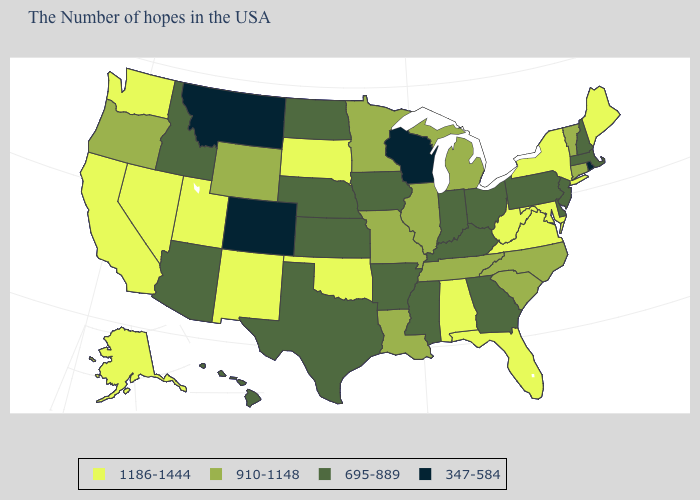What is the highest value in the USA?
Write a very short answer. 1186-1444. How many symbols are there in the legend?
Write a very short answer. 4. What is the value of Connecticut?
Answer briefly. 910-1148. Is the legend a continuous bar?
Quick response, please. No. Which states have the highest value in the USA?
Be succinct. Maine, New York, Maryland, Virginia, West Virginia, Florida, Alabama, Oklahoma, South Dakota, New Mexico, Utah, Nevada, California, Washington, Alaska. Does Iowa have the highest value in the USA?
Answer briefly. No. Is the legend a continuous bar?
Quick response, please. No. Does New Hampshire have the lowest value in the Northeast?
Write a very short answer. No. Among the states that border Arkansas , does Oklahoma have the highest value?
Short answer required. Yes. What is the value of Idaho?
Quick response, please. 695-889. What is the lowest value in states that border Maryland?
Give a very brief answer. 695-889. Does Missouri have the same value as Minnesota?
Concise answer only. Yes. Among the states that border Illinois , which have the lowest value?
Keep it brief. Wisconsin. What is the highest value in states that border Connecticut?
Short answer required. 1186-1444. Which states have the highest value in the USA?
Concise answer only. Maine, New York, Maryland, Virginia, West Virginia, Florida, Alabama, Oklahoma, South Dakota, New Mexico, Utah, Nevada, California, Washington, Alaska. 